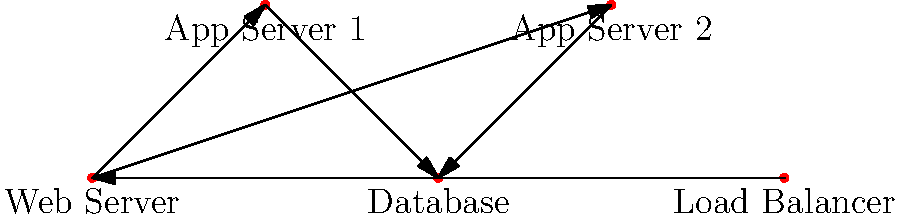Based on the network topology diagram, which component is most likely to become a bottleneck during a major code update, potentially causing your light-hearted bet on code survival to backfire? To identify the potential bottleneck in this network topology, let's analyze each component step-by-step:

1. Load Balancer: This distributes incoming traffic across multiple servers, which helps prevent any single server from becoming overwhelmed.

2. Web Server: This is a single point that all requests must pass through after the load balancer. It could become a bottleneck if it can't handle the volume of requests.

3. App Servers (1 and 2): There are two of these, which provides some redundancy and load distribution.

4. Database: This is a single component that both App Servers connect to. All data operations must go through this single point.

In a DevOps context, during a major code update:

- The Load Balancer is unlikely to be affected unless the update changes how traffic is routed.
- The Web Server might face increased load but can often be scaled horizontally if needed.
- The App Servers are where the new code will be deployed. Having two servers allows for rolling updates and provides some resilience.
- The Database is a single point that both App Servers depend on. If the code update involves database schema changes or increases database operations, this could become a significant bottleneck.

Given that the Database is a single point of failure that all data-dependent operations must pass through, it's the most likely component to become a bottleneck during a major update.
Answer: Database 